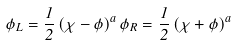Convert formula to latex. <formula><loc_0><loc_0><loc_500><loc_500>\phi _ { L } = \frac { 1 } { 2 } \left ( \chi - \phi \right ) ^ { a } \phi _ { R } = \frac { 1 } { 2 } \left ( \chi + \phi \right ) ^ { a }</formula> 